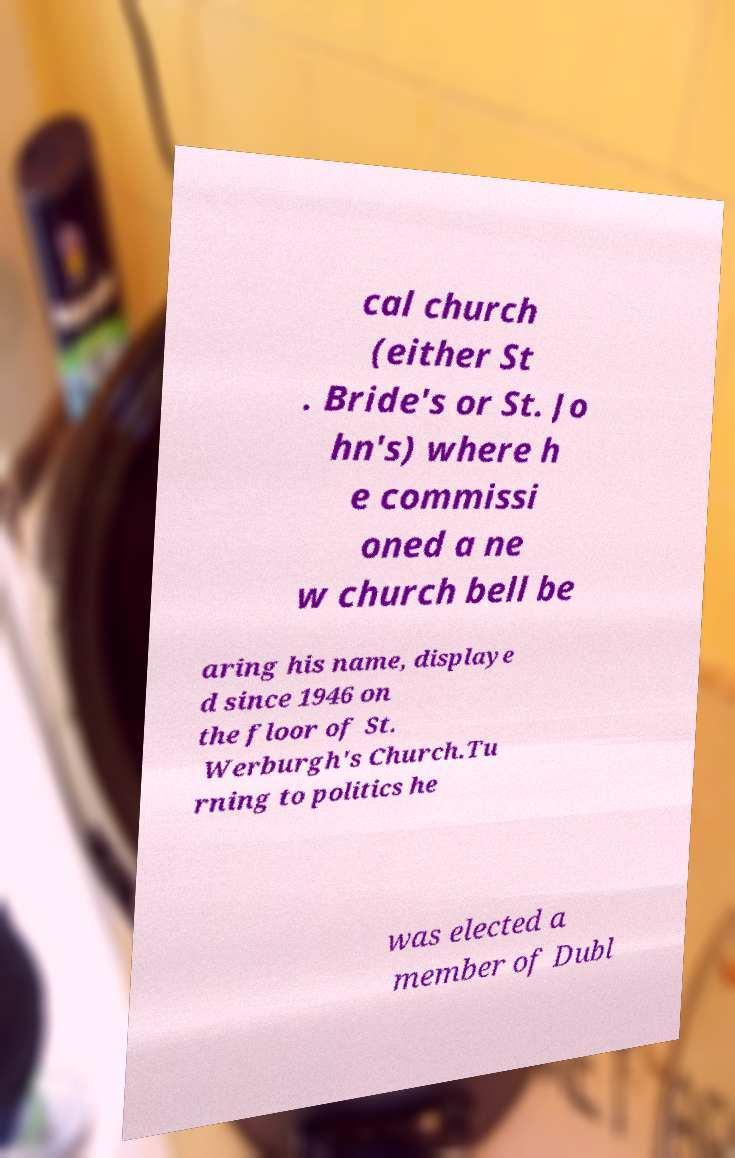Please read and relay the text visible in this image. What does it say? cal church (either St . Bride's or St. Jo hn's) where h e commissi oned a ne w church bell be aring his name, displaye d since 1946 on the floor of St. Werburgh's Church.Tu rning to politics he was elected a member of Dubl 